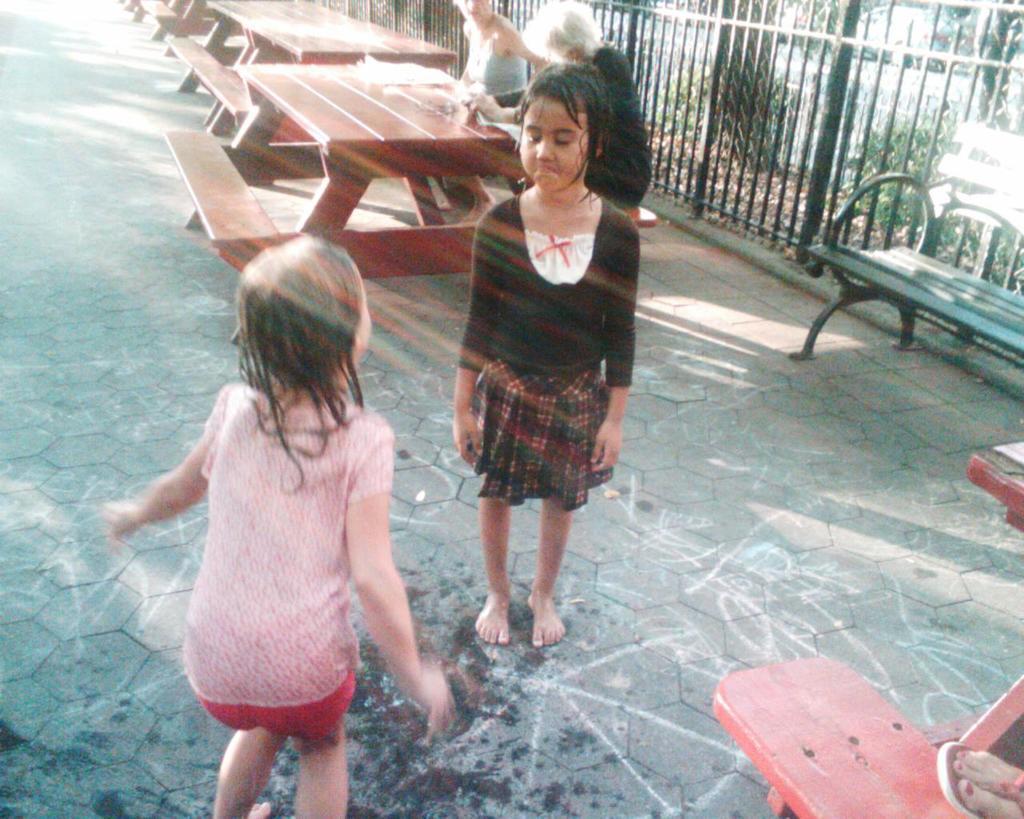How would you summarize this image in a sentence or two? there are two baby girls standing on a road behind them there is a bench and to all ladies sitting in it. 